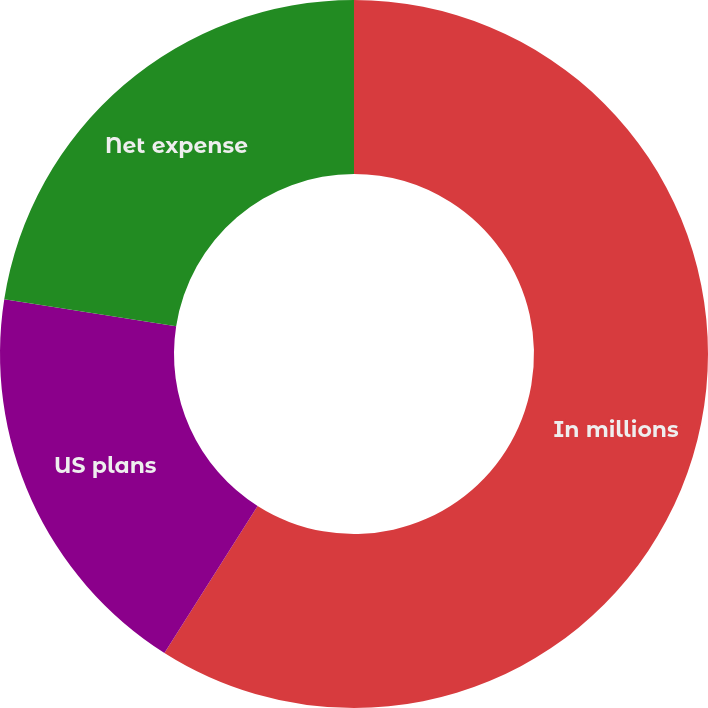<chart> <loc_0><loc_0><loc_500><loc_500><pie_chart><fcel>In millions<fcel>US plans<fcel>Net expense<nl><fcel>59.0%<fcel>18.48%<fcel>22.53%<nl></chart> 